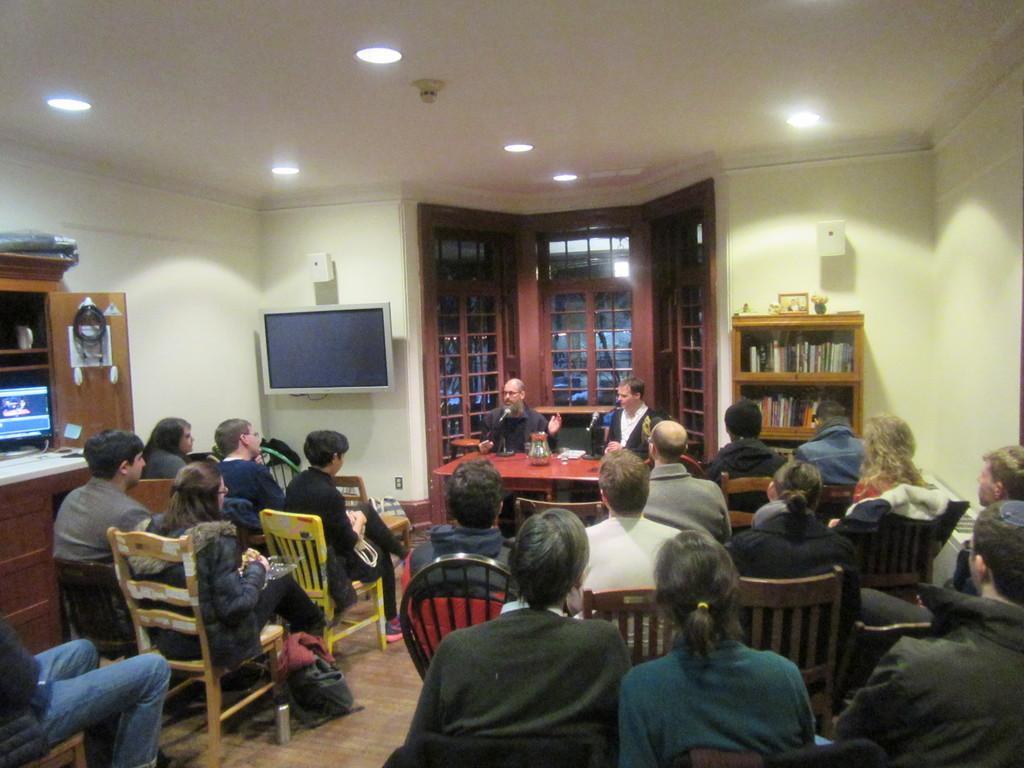Describe this image in one or two sentences. In this image we can see a few people sitting on the chairs, there are some objects on the table, there is a mic, there are bags, there are books on the rack, there is a TV, there are windows, there is a monitor and some other objects on the table, there are lights, also we can see the roof, and the wall. 